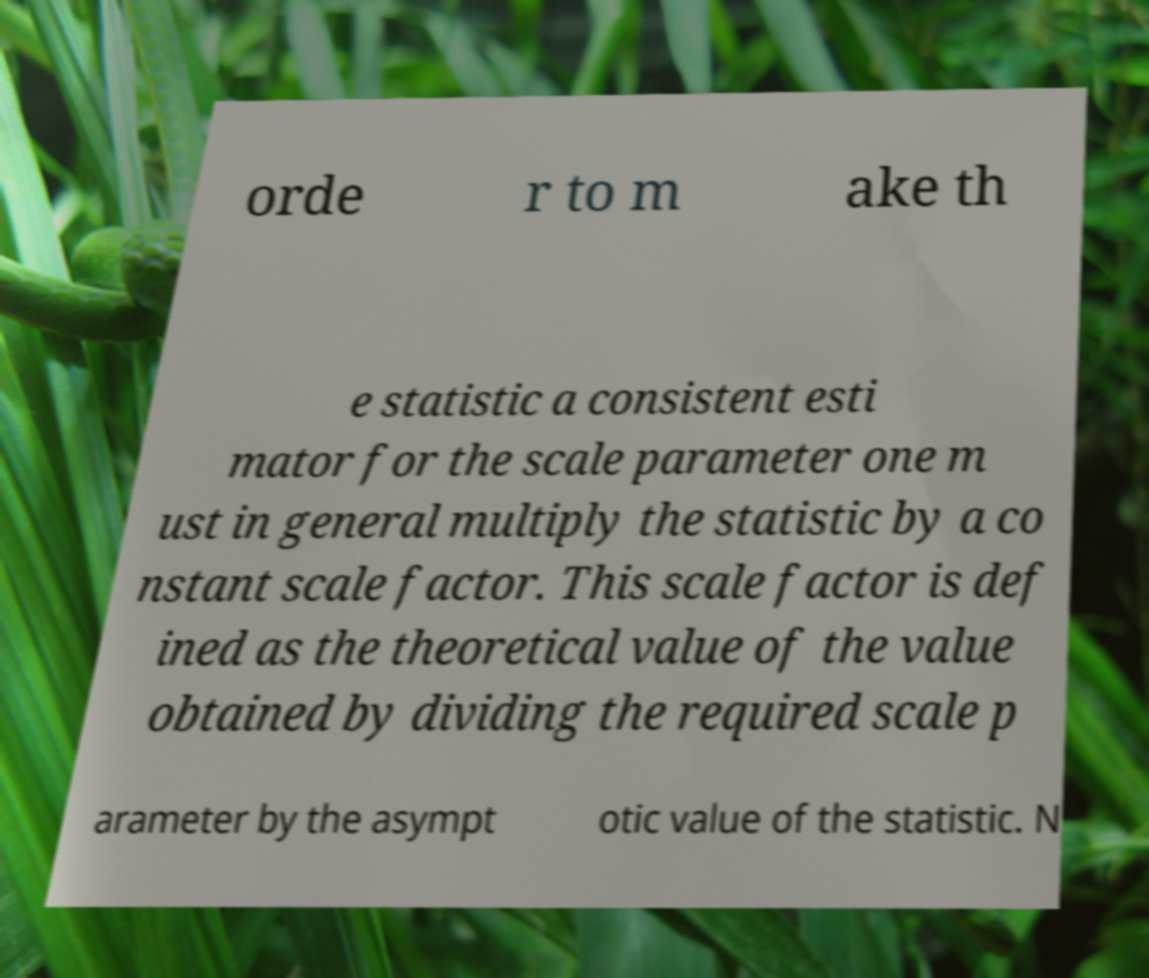Can you accurately transcribe the text from the provided image for me? orde r to m ake th e statistic a consistent esti mator for the scale parameter one m ust in general multiply the statistic by a co nstant scale factor. This scale factor is def ined as the theoretical value of the value obtained by dividing the required scale p arameter by the asympt otic value of the statistic. N 